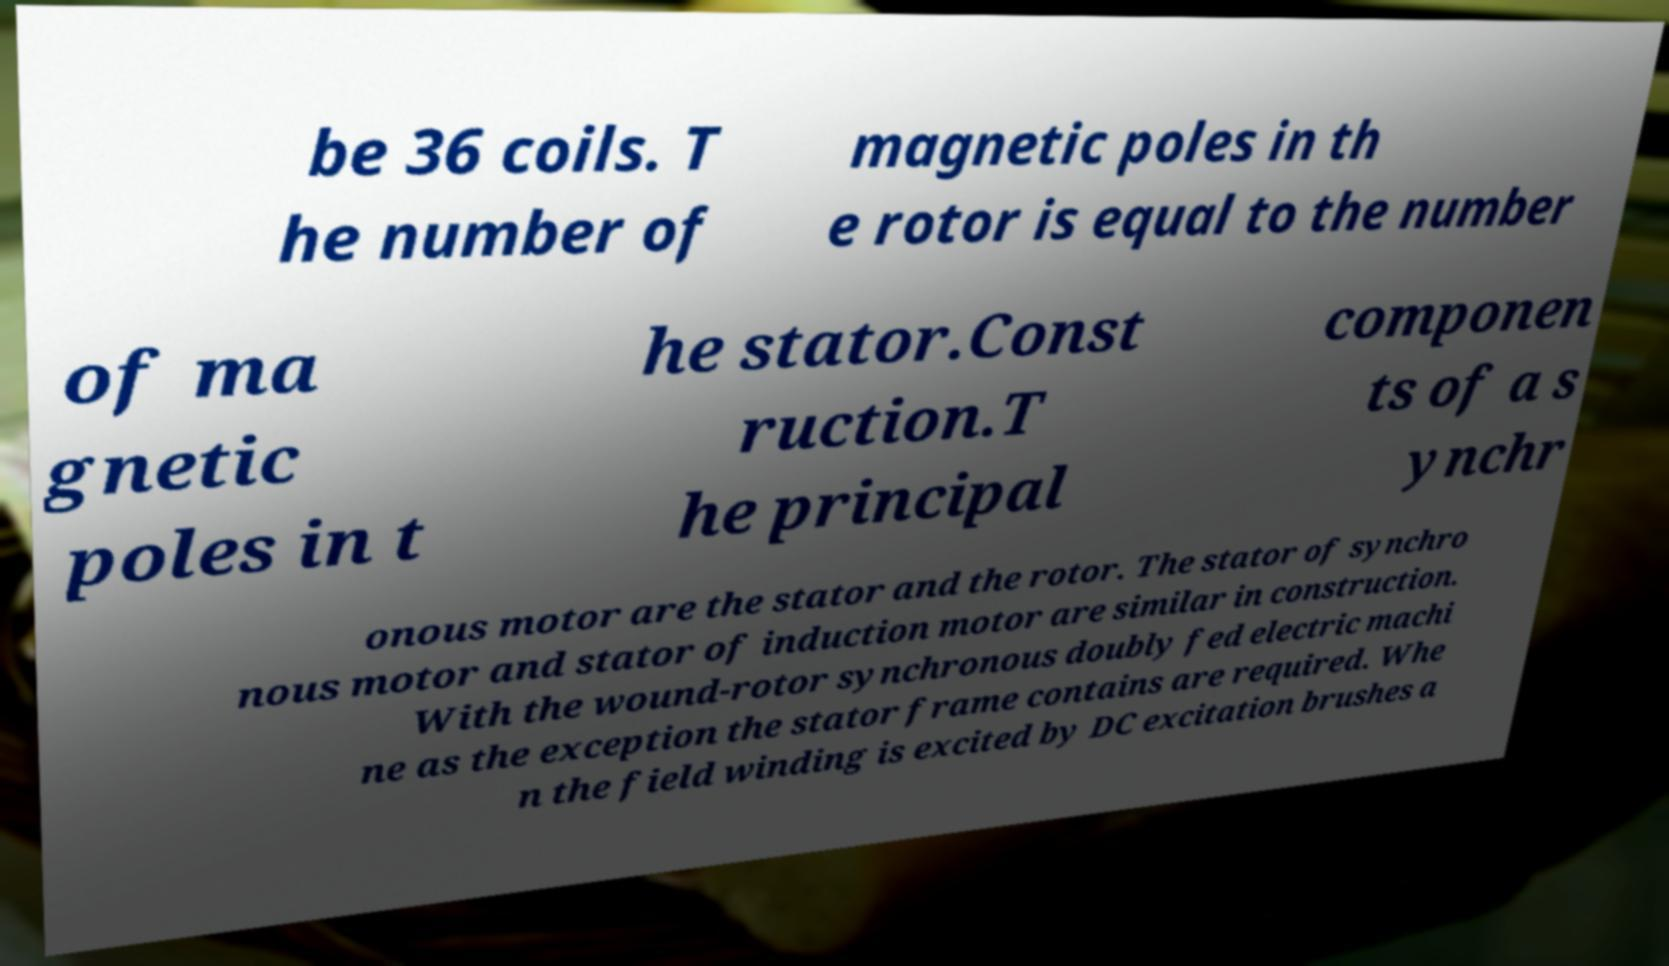Could you assist in decoding the text presented in this image and type it out clearly? be 36 coils. T he number of magnetic poles in th e rotor is equal to the number of ma gnetic poles in t he stator.Const ruction.T he principal componen ts of a s ynchr onous motor are the stator and the rotor. The stator of synchro nous motor and stator of induction motor are similar in construction. With the wound-rotor synchronous doubly fed electric machi ne as the exception the stator frame contains are required. Whe n the field winding is excited by DC excitation brushes a 